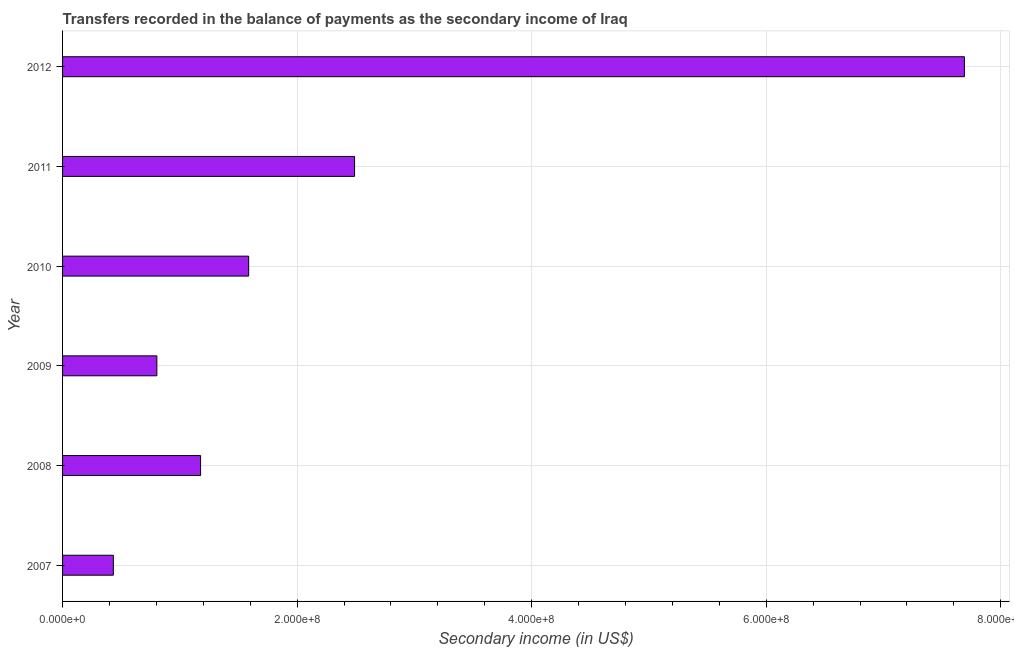Does the graph contain any zero values?
Your answer should be very brief. No. Does the graph contain grids?
Your answer should be compact. Yes. What is the title of the graph?
Make the answer very short. Transfers recorded in the balance of payments as the secondary income of Iraq. What is the label or title of the X-axis?
Give a very brief answer. Secondary income (in US$). What is the amount of secondary income in 2010?
Give a very brief answer. 1.59e+08. Across all years, what is the maximum amount of secondary income?
Your answer should be compact. 7.69e+08. Across all years, what is the minimum amount of secondary income?
Ensure brevity in your answer.  4.33e+07. In which year was the amount of secondary income maximum?
Your answer should be very brief. 2012. What is the sum of the amount of secondary income?
Your answer should be very brief. 1.42e+09. What is the difference between the amount of secondary income in 2009 and 2011?
Offer a very short reply. -1.69e+08. What is the average amount of secondary income per year?
Your answer should be very brief. 2.36e+08. What is the median amount of secondary income?
Provide a succinct answer. 1.38e+08. In how many years, is the amount of secondary income greater than 360000000 US$?
Your response must be concise. 1. Do a majority of the years between 2008 and 2009 (inclusive) have amount of secondary income greater than 760000000 US$?
Provide a succinct answer. No. What is the ratio of the amount of secondary income in 2011 to that in 2012?
Offer a very short reply. 0.32. Is the amount of secondary income in 2008 less than that in 2010?
Keep it short and to the point. Yes. Is the difference between the amount of secondary income in 2009 and 2010 greater than the difference between any two years?
Make the answer very short. No. What is the difference between the highest and the second highest amount of secondary income?
Provide a succinct answer. 5.20e+08. Is the sum of the amount of secondary income in 2010 and 2011 greater than the maximum amount of secondary income across all years?
Make the answer very short. No. What is the difference between the highest and the lowest amount of secondary income?
Provide a succinct answer. 7.26e+08. In how many years, is the amount of secondary income greater than the average amount of secondary income taken over all years?
Provide a succinct answer. 2. Are all the bars in the graph horizontal?
Make the answer very short. Yes. Are the values on the major ticks of X-axis written in scientific E-notation?
Your response must be concise. Yes. What is the Secondary income (in US$) in 2007?
Your answer should be very brief. 4.33e+07. What is the Secondary income (in US$) of 2008?
Your answer should be very brief. 1.18e+08. What is the Secondary income (in US$) in 2009?
Provide a succinct answer. 8.04e+07. What is the Secondary income (in US$) in 2010?
Your response must be concise. 1.59e+08. What is the Secondary income (in US$) in 2011?
Offer a very short reply. 2.49e+08. What is the Secondary income (in US$) in 2012?
Make the answer very short. 7.69e+08. What is the difference between the Secondary income (in US$) in 2007 and 2008?
Your response must be concise. -7.44e+07. What is the difference between the Secondary income (in US$) in 2007 and 2009?
Keep it short and to the point. -3.71e+07. What is the difference between the Secondary income (in US$) in 2007 and 2010?
Your answer should be very brief. -1.15e+08. What is the difference between the Secondary income (in US$) in 2007 and 2011?
Keep it short and to the point. -2.06e+08. What is the difference between the Secondary income (in US$) in 2007 and 2012?
Keep it short and to the point. -7.26e+08. What is the difference between the Secondary income (in US$) in 2008 and 2009?
Offer a very short reply. 3.73e+07. What is the difference between the Secondary income (in US$) in 2008 and 2010?
Ensure brevity in your answer.  -4.10e+07. What is the difference between the Secondary income (in US$) in 2008 and 2011?
Your answer should be compact. -1.31e+08. What is the difference between the Secondary income (in US$) in 2008 and 2012?
Provide a short and direct response. -6.51e+08. What is the difference between the Secondary income (in US$) in 2009 and 2010?
Give a very brief answer. -7.83e+07. What is the difference between the Secondary income (in US$) in 2009 and 2011?
Provide a succinct answer. -1.69e+08. What is the difference between the Secondary income (in US$) in 2009 and 2012?
Ensure brevity in your answer.  -6.89e+08. What is the difference between the Secondary income (in US$) in 2010 and 2011?
Your response must be concise. -9.03e+07. What is the difference between the Secondary income (in US$) in 2010 and 2012?
Offer a very short reply. -6.10e+08. What is the difference between the Secondary income (in US$) in 2011 and 2012?
Provide a short and direct response. -5.20e+08. What is the ratio of the Secondary income (in US$) in 2007 to that in 2008?
Your response must be concise. 0.37. What is the ratio of the Secondary income (in US$) in 2007 to that in 2009?
Provide a short and direct response. 0.54. What is the ratio of the Secondary income (in US$) in 2007 to that in 2010?
Offer a very short reply. 0.27. What is the ratio of the Secondary income (in US$) in 2007 to that in 2011?
Provide a succinct answer. 0.17. What is the ratio of the Secondary income (in US$) in 2007 to that in 2012?
Provide a succinct answer. 0.06. What is the ratio of the Secondary income (in US$) in 2008 to that in 2009?
Give a very brief answer. 1.46. What is the ratio of the Secondary income (in US$) in 2008 to that in 2010?
Your answer should be compact. 0.74. What is the ratio of the Secondary income (in US$) in 2008 to that in 2011?
Make the answer very short. 0.47. What is the ratio of the Secondary income (in US$) in 2008 to that in 2012?
Ensure brevity in your answer.  0.15. What is the ratio of the Secondary income (in US$) in 2009 to that in 2010?
Your response must be concise. 0.51. What is the ratio of the Secondary income (in US$) in 2009 to that in 2011?
Ensure brevity in your answer.  0.32. What is the ratio of the Secondary income (in US$) in 2009 to that in 2012?
Your answer should be very brief. 0.1. What is the ratio of the Secondary income (in US$) in 2010 to that in 2011?
Your answer should be very brief. 0.64. What is the ratio of the Secondary income (in US$) in 2010 to that in 2012?
Offer a very short reply. 0.21. What is the ratio of the Secondary income (in US$) in 2011 to that in 2012?
Keep it short and to the point. 0.32. 